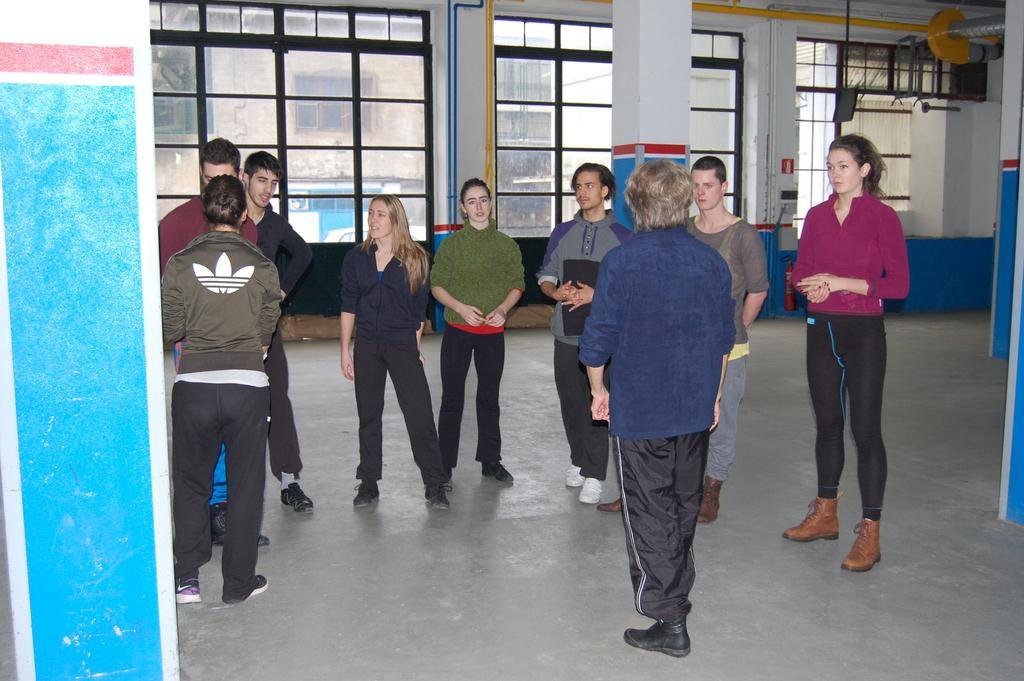Describe this image in one or two sentences. In this picture, we see the man and the women are standing. On the left side, we see a pillar in white and blue color. Behind them, we see a pillar. In the background, we see a wall in white and blue color. We see the glass windows from which we can see the buildings and the trees. On the right side, we see the pillars and a rod in yellow color. 